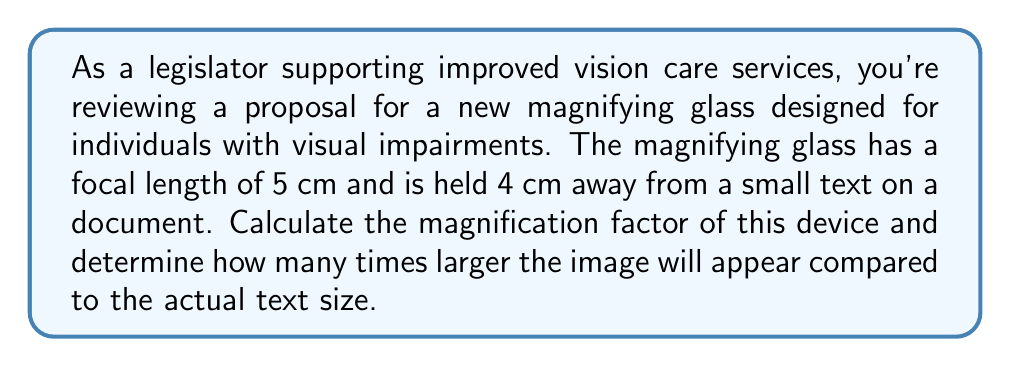Could you help me with this problem? To solve this problem, we'll use the magnification formula for a magnifying glass:

$$M = 1 + \frac{D}{f}$$

Where:
$M$ = magnification factor
$D$ = distance from the lens to the eye (typically 25 cm for near point)
$f$ = focal length of the lens

Given:
- Focal length $(f) = 5$ cm
- Distance from lens to object = 4 cm

Step 1: Calculate the image distance $(d_i)$ using the thin lens equation:
$$\frac{1}{f} = \frac{1}{d_o} + \frac{1}{d_i}$$
$$\frac{1}{5} = \frac{1}{4} + \frac{1}{d_i}$$
$$\frac{1}{d_i} = \frac{1}{5} - \frac{1}{4} = \frac{4-5}{20} = -\frac{1}{20}$$
$$d_i = -20 \text{ cm}$$

The negative sign indicates the image is virtual and on the same side as the object.

Step 2: Calculate the magnification factor:
$$M = 1 + \frac{D}{f} = 1 + \frac{25}{5} = 1 + 5 = 6$$

Therefore, the magnification factor is 6, meaning the image will appear 6 times larger than the actual text size.
Answer: The magnification factor is 6, and the image will appear 6 times larger than the actual text size. 